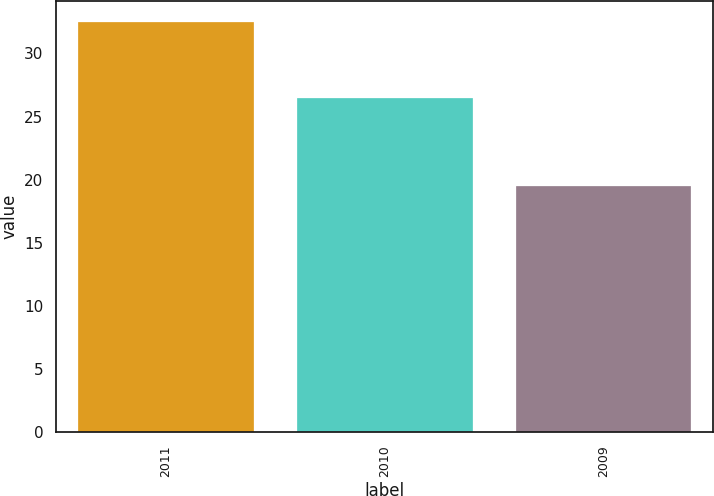Convert chart to OTSL. <chart><loc_0><loc_0><loc_500><loc_500><bar_chart><fcel>2011<fcel>2010<fcel>2009<nl><fcel>32.5<fcel>26.5<fcel>19.5<nl></chart> 